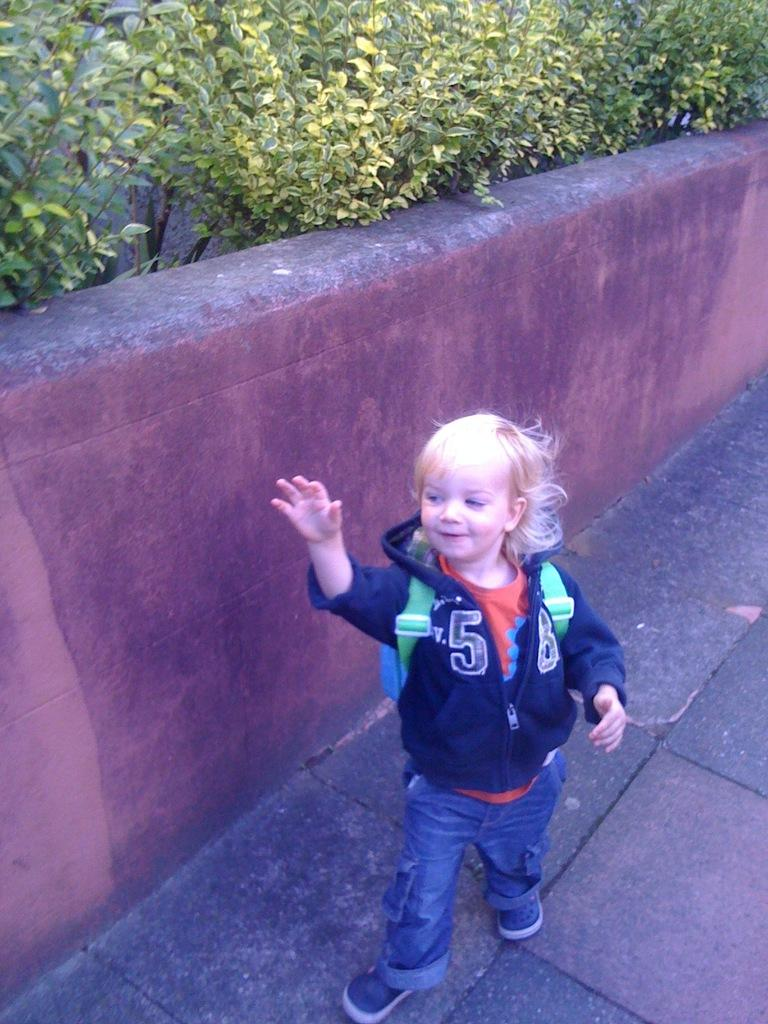<image>
Give a short and clear explanation of the subsequent image. A little boy wearing a backpack and a sweatshirt with number 58 on it. 